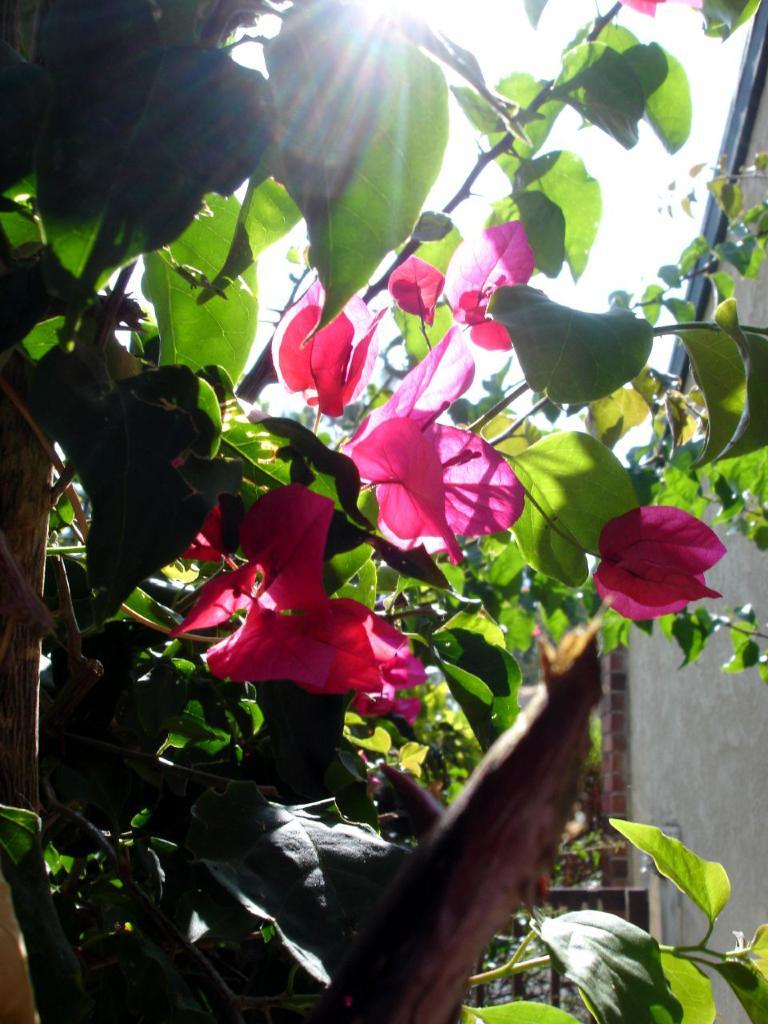What type of plant life is visible in the image? There are flowers, leaves, and stems in the image. Can you describe the background of the image? There is a wall in the background of the image. What type of toys can be seen playing with the flowers in the image? There are no toys present in the image, and therefore no such activity can be observed. 